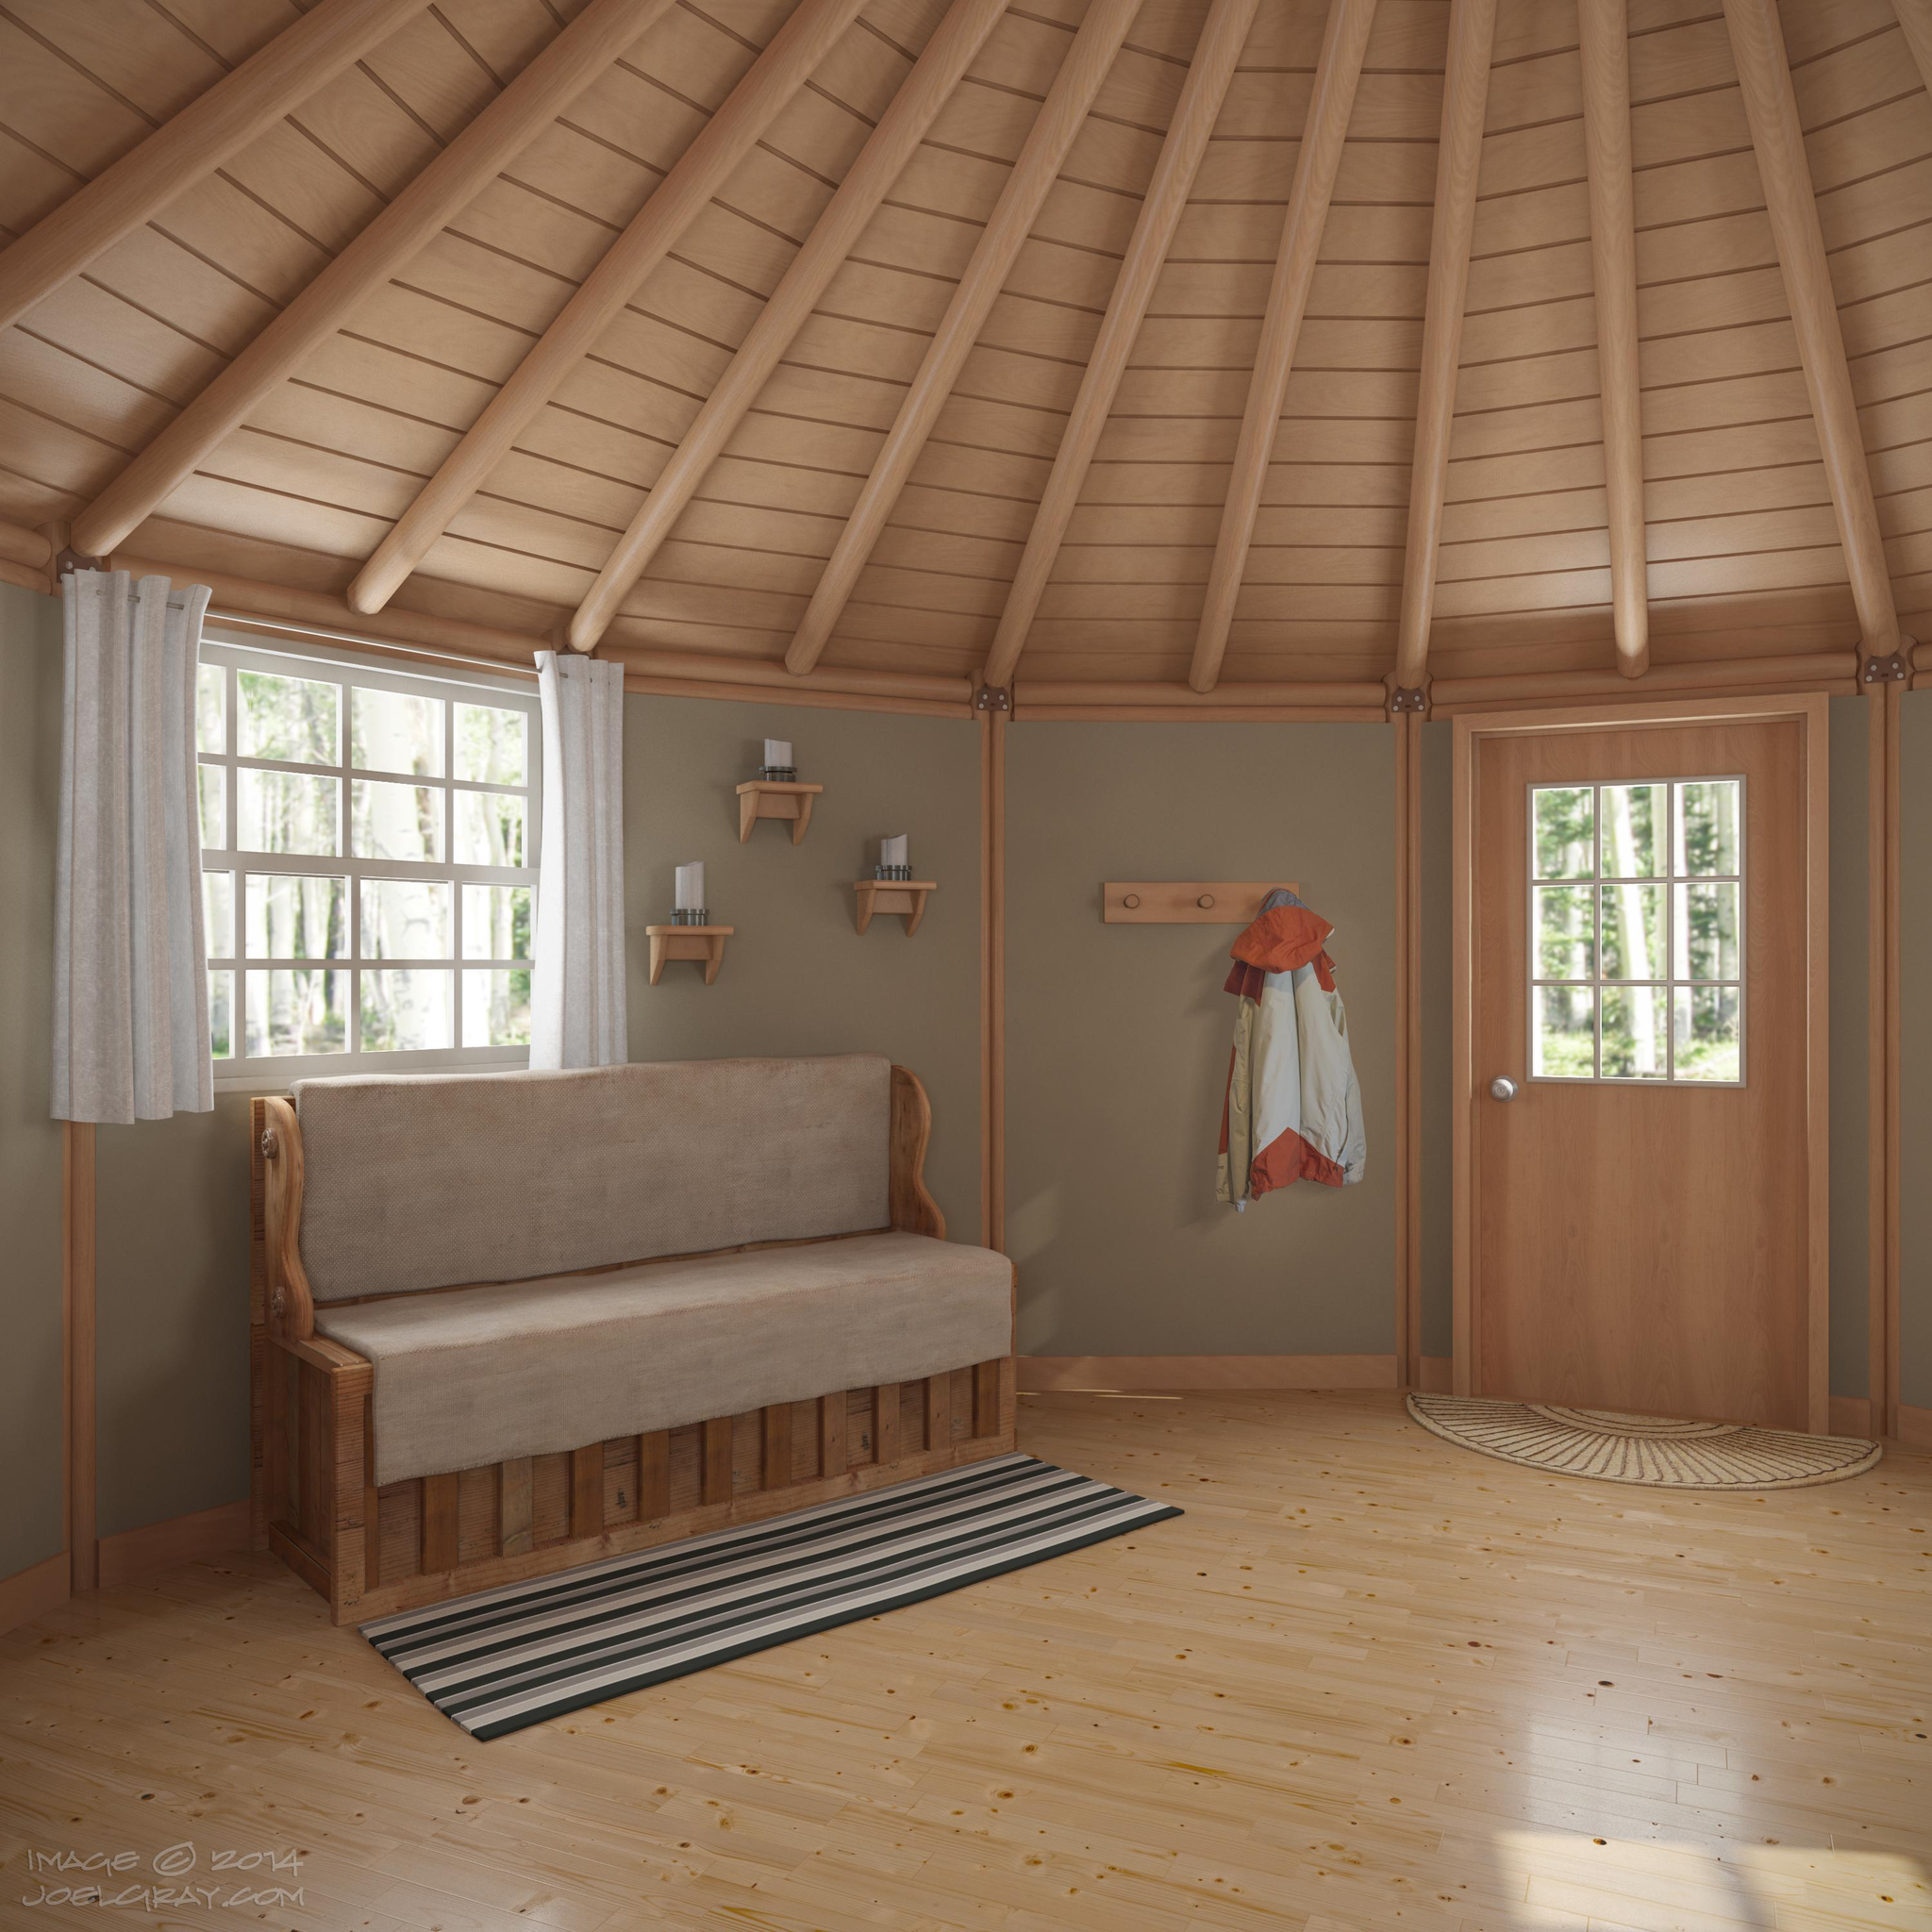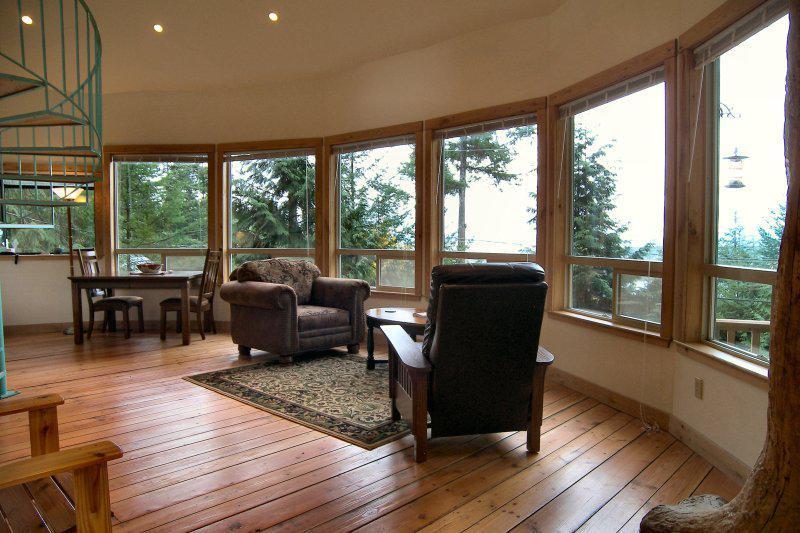The first image is the image on the left, the second image is the image on the right. Analyze the images presented: Is the assertion "One image shows the kitchen of a yurt with white refrigerator and microwave and a vase of flowers near a dining seating area with wooden kitchen chairs." valid? Answer yes or no. No. The first image is the image on the left, the second image is the image on the right. Examine the images to the left and right. Is the description "A ceiling fan is hanging above a kitchen in the left image." accurate? Answer yes or no. No. 